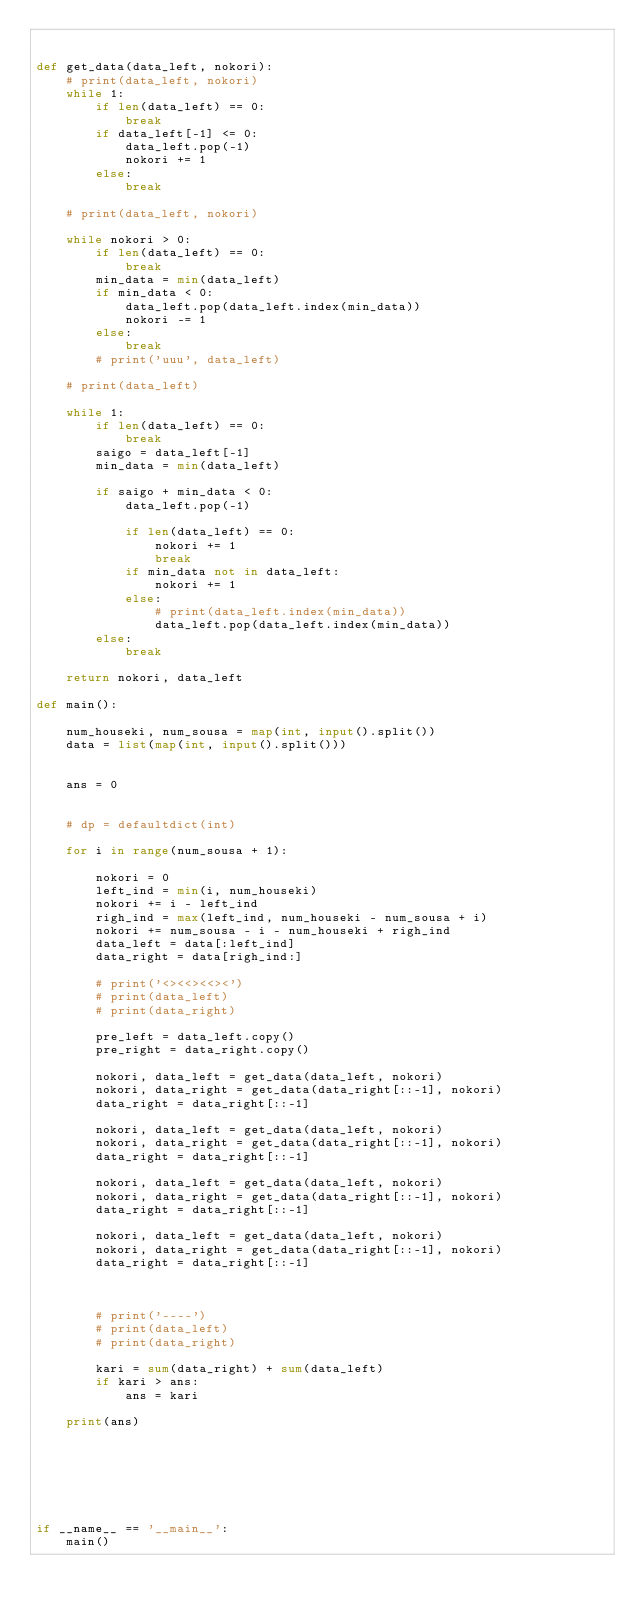<code> <loc_0><loc_0><loc_500><loc_500><_Python_>

def get_data(data_left, nokori):
    # print(data_left, nokori)
    while 1:
        if len(data_left) == 0:
            break
        if data_left[-1] <= 0:
            data_left.pop(-1)
            nokori += 1
        else:
            break

    # print(data_left, nokori)

    while nokori > 0:
        if len(data_left) == 0:
            break
        min_data = min(data_left)
        if min_data < 0:
            data_left.pop(data_left.index(min_data))
            nokori -= 1
        else:
            break
        # print('uuu', data_left)

    # print(data_left)

    while 1:
        if len(data_left) == 0:
            break
        saigo = data_left[-1]
        min_data = min(data_left)

        if saigo + min_data < 0:
            data_left.pop(-1)

            if len(data_left) == 0:
                nokori += 1
                break
            if min_data not in data_left:
                nokori += 1
            else:
                # print(data_left.index(min_data))
                data_left.pop(data_left.index(min_data))
        else:
            break

    return nokori, data_left

def main():

    num_houseki, num_sousa = map(int, input().split())
    data = list(map(int, input().split()))


    ans = 0


    # dp = defaultdict(int)

    for i in range(num_sousa + 1):

        nokori = 0
        left_ind = min(i, num_houseki)
        nokori += i - left_ind
        righ_ind = max(left_ind, num_houseki - num_sousa + i)
        nokori += num_sousa - i - num_houseki + righ_ind
        data_left = data[:left_ind]
        data_right = data[righ_ind:]

        # print('<><<><<><')
        # print(data_left)
        # print(data_right)

        pre_left = data_left.copy()
        pre_right = data_right.copy()

        nokori, data_left = get_data(data_left, nokori)
        nokori, data_right = get_data(data_right[::-1], nokori)
        data_right = data_right[::-1]

        nokori, data_left = get_data(data_left, nokori)
        nokori, data_right = get_data(data_right[::-1], nokori)
        data_right = data_right[::-1]

        nokori, data_left = get_data(data_left, nokori)
        nokori, data_right = get_data(data_right[::-1], nokori)
        data_right = data_right[::-1]

        nokori, data_left = get_data(data_left, nokori)
        nokori, data_right = get_data(data_right[::-1], nokori)
        data_right = data_right[::-1]



        # print('----')
        # print(data_left)
        # print(data_right)

        kari = sum(data_right) + sum(data_left)
        if kari > ans:
            ans = kari

    print(ans)







if __name__ == '__main__':
    main()
</code> 